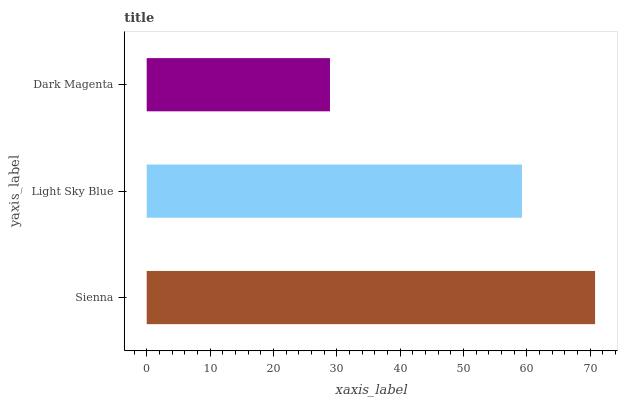Is Dark Magenta the minimum?
Answer yes or no. Yes. Is Sienna the maximum?
Answer yes or no. Yes. Is Light Sky Blue the minimum?
Answer yes or no. No. Is Light Sky Blue the maximum?
Answer yes or no. No. Is Sienna greater than Light Sky Blue?
Answer yes or no. Yes. Is Light Sky Blue less than Sienna?
Answer yes or no. Yes. Is Light Sky Blue greater than Sienna?
Answer yes or no. No. Is Sienna less than Light Sky Blue?
Answer yes or no. No. Is Light Sky Blue the high median?
Answer yes or no. Yes. Is Light Sky Blue the low median?
Answer yes or no. Yes. Is Sienna the high median?
Answer yes or no. No. Is Sienna the low median?
Answer yes or no. No. 